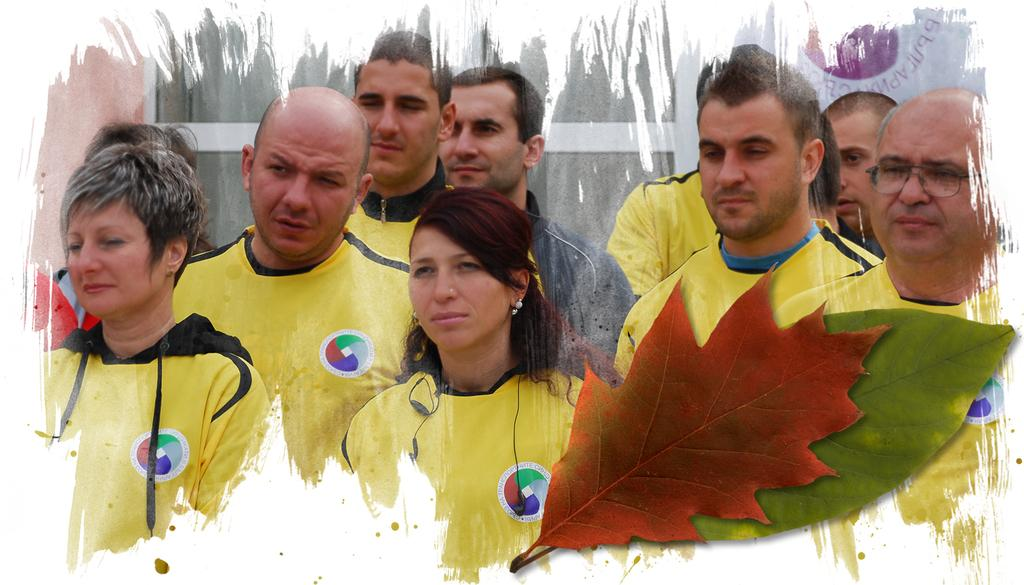What is happening in the image? There are people standing in the image. What can be seen in the foreground of the image? There are two leaves in the foreground of the image. What is visible in the background of the image? There is a building in the background of the image. How many passengers are sitting on the toad in the image? There is no toad or passengers present in the image. 